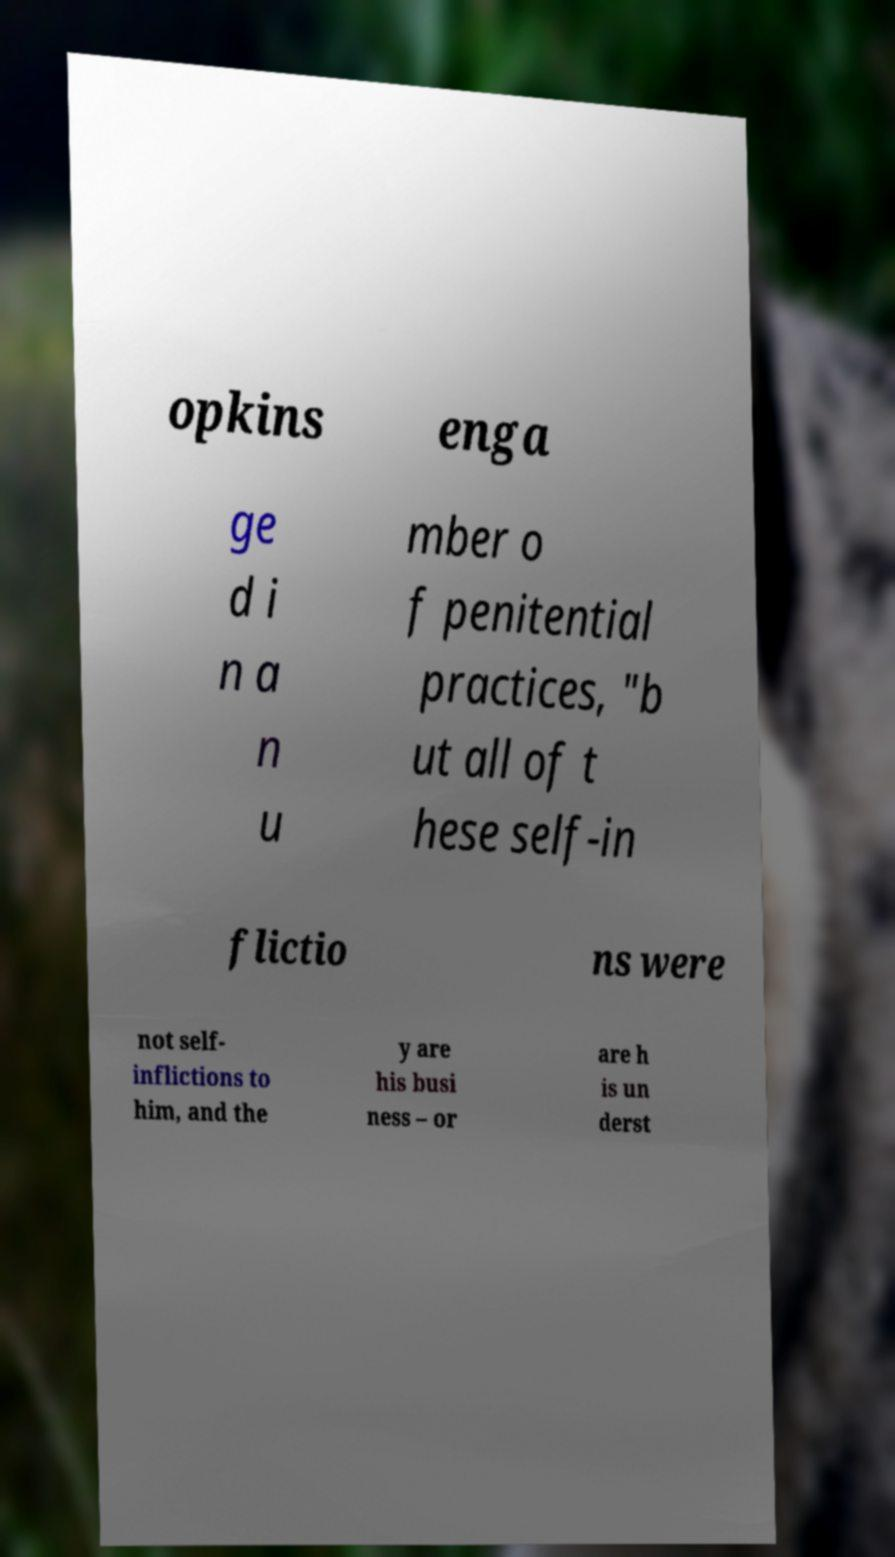For documentation purposes, I need the text within this image transcribed. Could you provide that? opkins enga ge d i n a n u mber o f penitential practices, "b ut all of t hese self-in flictio ns were not self- inflictions to him, and the y are his busi ness – or are h is un derst 